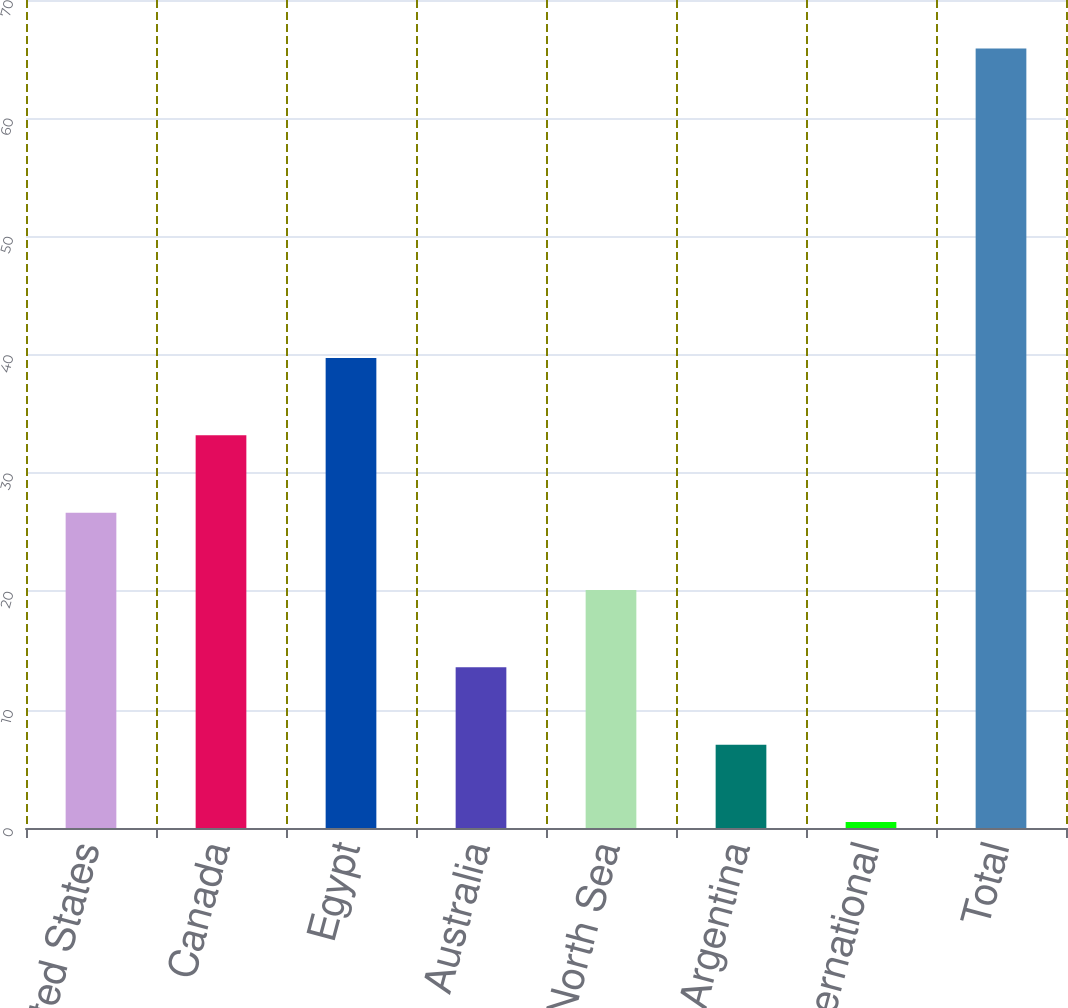Convert chart. <chart><loc_0><loc_0><loc_500><loc_500><bar_chart><fcel>United States<fcel>Canada<fcel>Egypt<fcel>Australia<fcel>North Sea<fcel>Argentina<fcel>Other International<fcel>Total<nl><fcel>26.66<fcel>33.2<fcel>39.74<fcel>13.58<fcel>20.12<fcel>7.04<fcel>0.5<fcel>65.9<nl></chart> 